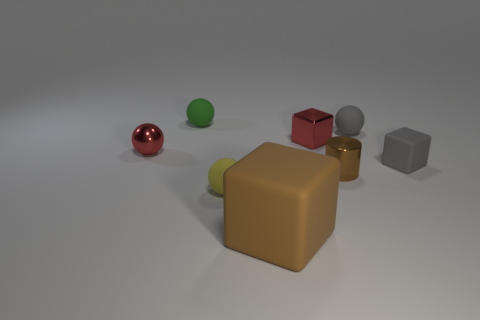Add 1 green matte spheres. How many objects exist? 9 Subtract all cylinders. How many objects are left? 7 Add 6 small balls. How many small balls exist? 10 Subtract 0 purple blocks. How many objects are left? 8 Subtract all small red rubber cubes. Subtract all tiny red shiny blocks. How many objects are left? 7 Add 1 small yellow things. How many small yellow things are left? 2 